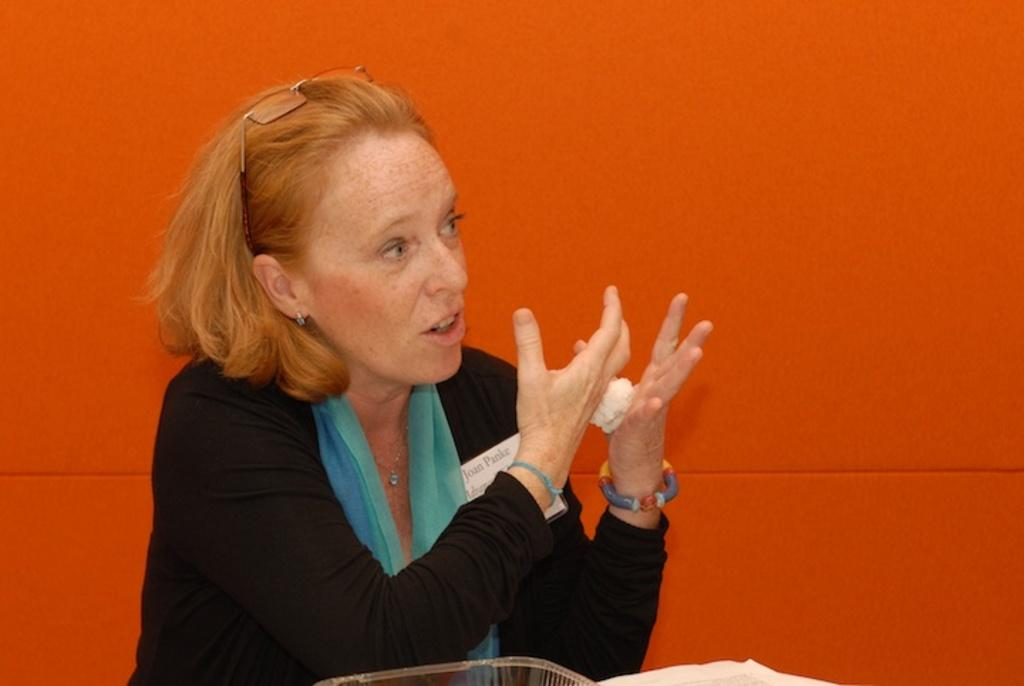Who is the main subject in the image? There is a woman in the center of the image. What can be seen in the background of the image? There is an orange color wall in the background of the image. What type of wine is the woman holding in the image? There is no wine present in the image; the woman is not holding anything. 